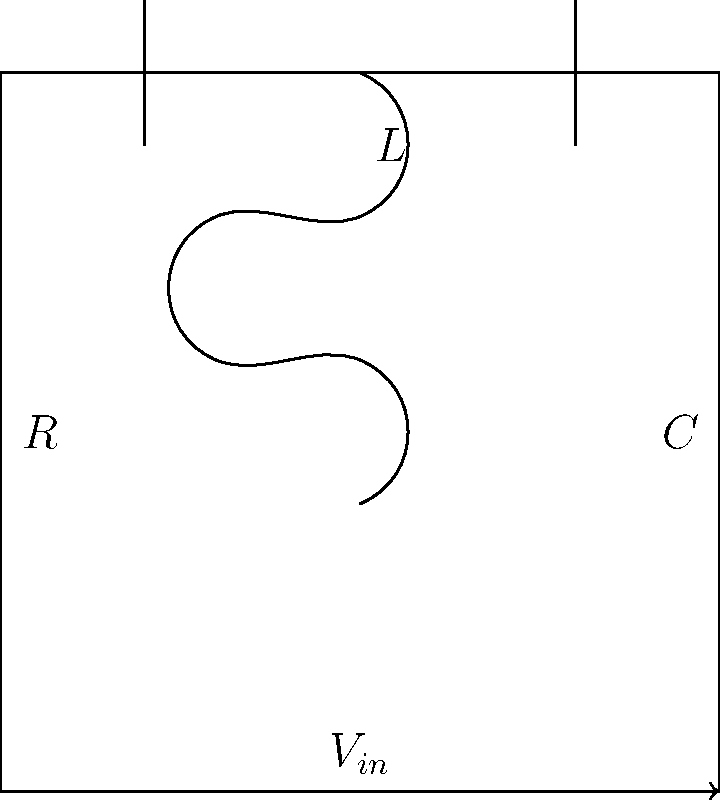As a singer-songwriter inspired by Loretta Heywood's music, you're exploring the connection between electrical circuits and sound waves. Consider the RLC circuit shown above, where $R = 100 \Omega$, $L = 50 \text{ mH}$, and $C = 10 \mu\text{F}$. Calculate the resonant frequency of this circuit, which could represent the frequency of a pure musical tone. Express your answer in Hz, rounded to the nearest whole number. To find the resonant frequency of an RLC circuit, we use the formula:

$$ f_r = \frac{1}{2\pi\sqrt{LC}} $$

Where:
- $f_r$ is the resonant frequency in Hz
- $L$ is the inductance in Henries (H)
- $C$ is the capacitance in Farads (F)

Let's plug in our values:

$L = 50 \text{ mH} = 50 \times 10^{-3} \text{ H}$
$C = 10 \mu\text{F} = 10 \times 10^{-6} \text{ F}$

Now, let's calculate:

$$ f_r = \frac{1}{2\pi\sqrt{(50 \times 10^{-3})(10 \times 10^{-6})}} $$

$$ f_r = \frac{1}{2\pi\sqrt{500 \times 10^{-9}}} $$

$$ f_r = \frac{1}{2\pi\sqrt{5 \times 10^{-7}}} $$

$$ f_r = \frac{1}{2\pi \times 7.07 \times 10^{-4}} $$

$$ f_r \approx 225.08 \text{ Hz} $$

Rounding to the nearest whole number:

$$ f_r \approx 225 \text{ Hz} $$

This frequency falls within the range of musical notes, specifically between the A3 (220 Hz) and A3# (233.08 Hz) notes on a standard musical scale.
Answer: 225 Hz 